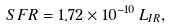Convert formula to latex. <formula><loc_0><loc_0><loc_500><loc_500>S F R = 1 . 7 2 \times 1 0 ^ { - 1 0 } \, L _ { I R } ,</formula> 